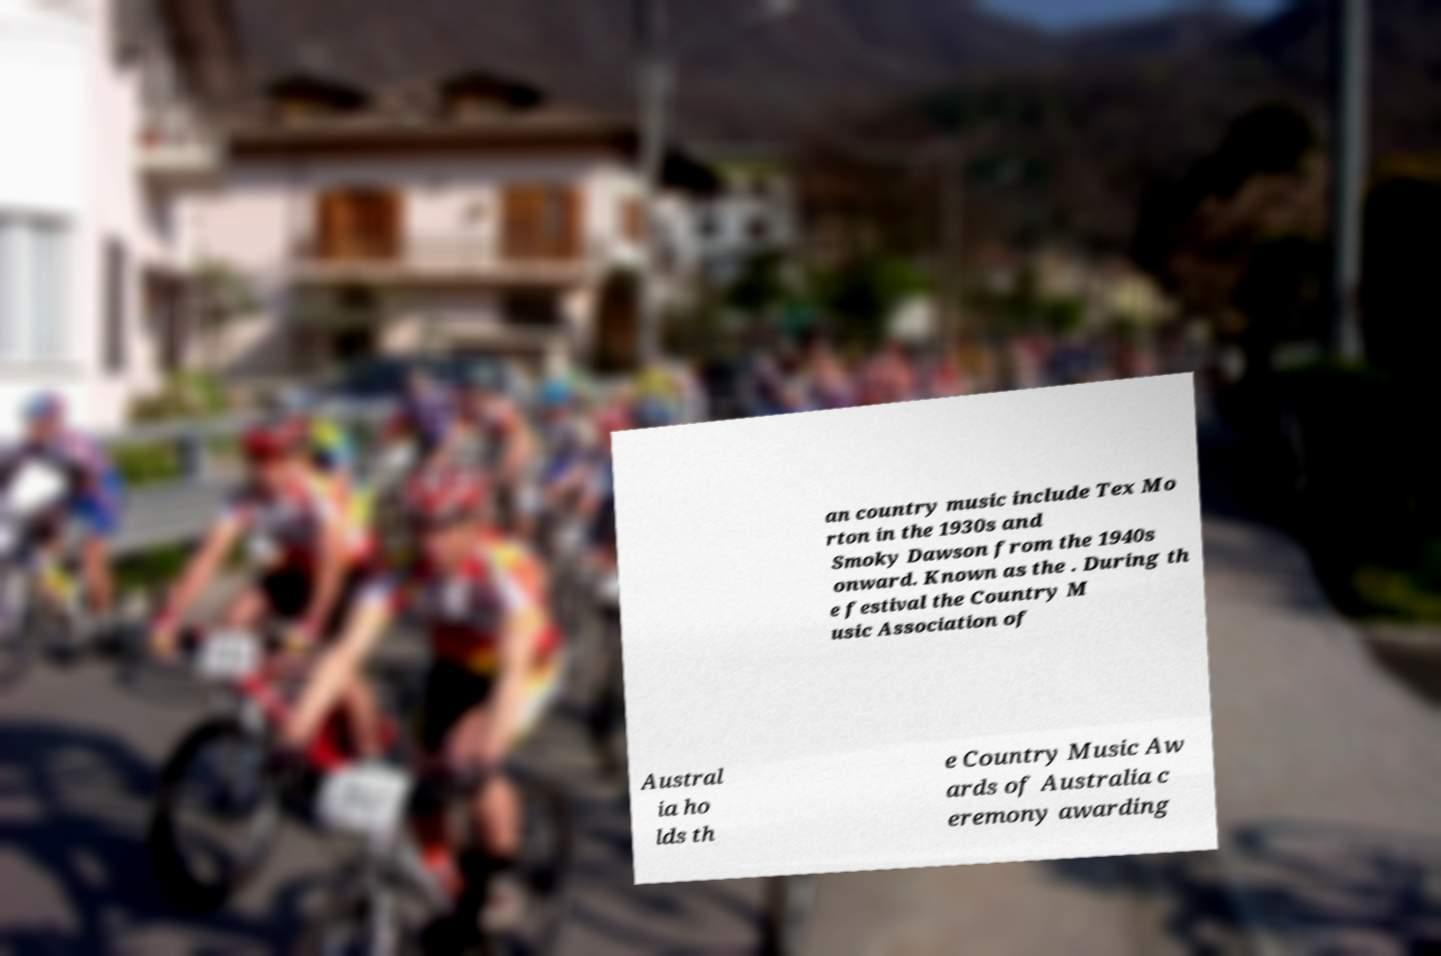Can you read and provide the text displayed in the image?This photo seems to have some interesting text. Can you extract and type it out for me? an country music include Tex Mo rton in the 1930s and Smoky Dawson from the 1940s onward. Known as the . During th e festival the Country M usic Association of Austral ia ho lds th e Country Music Aw ards of Australia c eremony awarding 